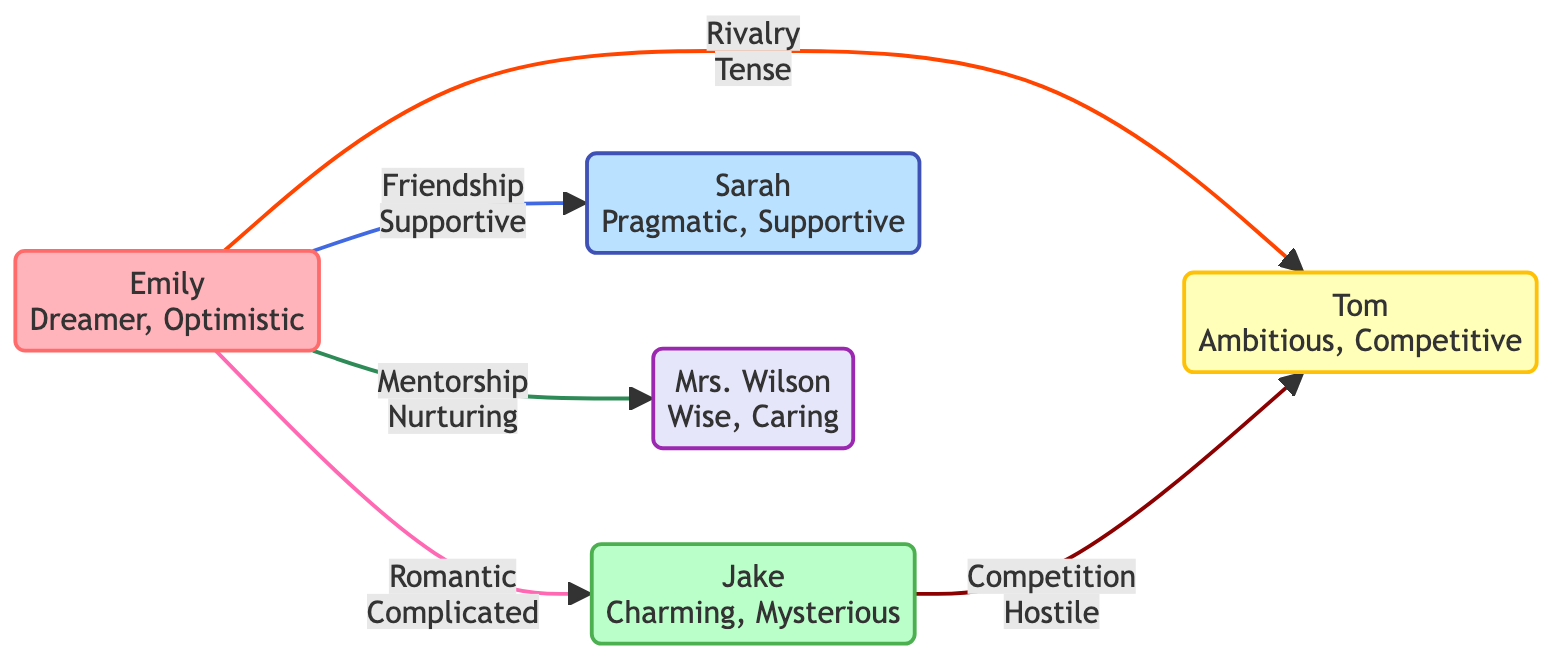What is Emily's role in the screenplay? In the diagram, Emily is clearly labeled as the "Protagonist," which identifies her primary role in the story.
Answer: Protagonist What type of relationship exists between Emily and Jake? The diagram specifies that the relationship between Emily and Jake is labeled as "romantic" with the status "complicated."
Answer: romantic How many characters are involved in the relationships depicted in the diagram? The diagram lists a total of five characters: Emily, Jake, Sarah, Tom, and Mrs. Wilson.
Answer: 5 What is the status of the rivalry between Emily and Tom? The diagram states that the status of the rivalry between Emily and Tom is "tense."
Answer: tense Which character has a mentoring relationship with Emily? Based on the connections in the diagram, Mrs. Wilson is the character noted to have a "mentorship" relationship with Emily.
Answer: Mrs. Wilson Between which two characters is there a hostile competition? The diagram indicates that there is a "hostile" competition between Jake and Tom, as denoted by the arrow connecting them with this relationship.
Answer: Jake and Tom How does Emily relate to Sarah? The diagram illustrates a "friendship" relationship between Emily and Sarah with the status "supportive."
Answer: friendship Which character's traits include being charming and mysterious? The diagram attributes the traits of being "charming" and "mysterious" to Jake, who is identified as the Love Interest.
Answer: Jake What type of relationship does Tom share with Jake? According to the diagram, Tom and Jake share a "competition" relationship, which is further qualified by the status "hostile."
Answer: competition 